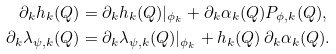Convert formula to latex. <formula><loc_0><loc_0><loc_500><loc_500>\partial _ { k } h _ { k } ( Q ) & = \partial _ { k } h _ { k } ( Q ) | _ { \phi _ { k } } + \partial _ { k } \alpha _ { k } ( Q ) P _ { \phi , k } ( Q ) , \\ \partial _ { k } \lambda _ { \psi , k } ( Q ) & = \partial _ { k } \lambda _ { \psi , k } ( Q ) | _ { \phi _ { k } } + h _ { k } ( Q ) \, \partial _ { k } \alpha _ { k } ( Q ) .</formula> 